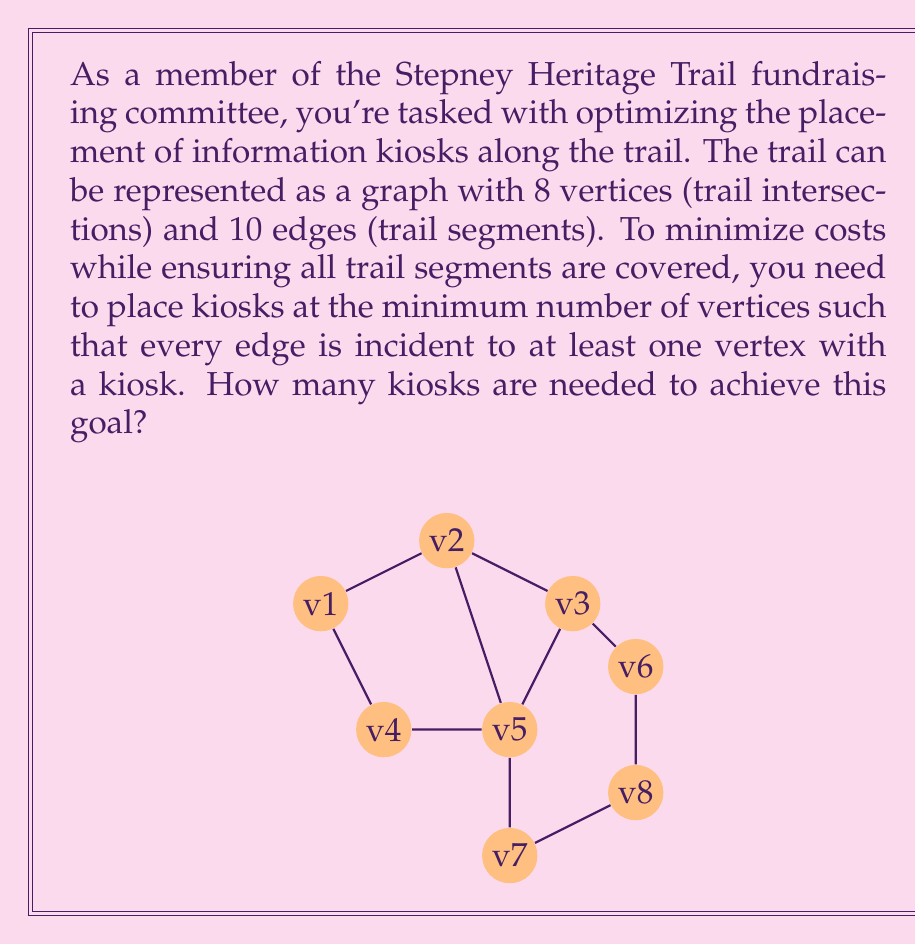What is the answer to this math problem? To solve this problem, we need to find the minimum vertex cover of the given graph. A vertex cover is a set of vertices such that every edge in the graph is incident to at least one vertex in the set. The minimum vertex cover represents the smallest number of kiosks needed to cover all trail segments.

Let's approach this step-by-step:

1) First, we observe that the graph has some degree-1 vertices (v1 and v5). Their adjacent vertices (v2 and v3 respectively) must be in the vertex cover to cover the edges incident to v1 and v5.

2) After including v2 and v3, we have covered the edges (v1,v2), (v2,v4), and (v3,v5).

3) Now, we need to cover the remaining edges. We can see that v4 and v7 together cover all the remaining edges:
   - v4 covers (v3,v4), (v4,v6), and (v4,v7)
   - v7 covers (v6,v7) and (v5,v7)

4) Therefore, a minimum vertex cover for this graph is {v2, v3, v4, v7}.

We can verify that this set covers all edges:
- (v1,v2) covered by v2
- (v2,v3) covered by v2 and v3
- (v2,v4) covered by v2 and v4
- (v3,v4) covered by v3 and v4
- (v3,v5) covered by v3
- (v4,v6) covered by v4
- (v4,v7) covered by v4 and v7
- (v5,v7) covered by v7
- (v6,v7) covered by v7

No smaller set of vertices can cover all edges, so this is indeed a minimum vertex cover.

The size of this minimum vertex cover is 4, which represents the minimum number of kiosks needed to cover all trail segments.
Answer: 4 kiosks are needed. 